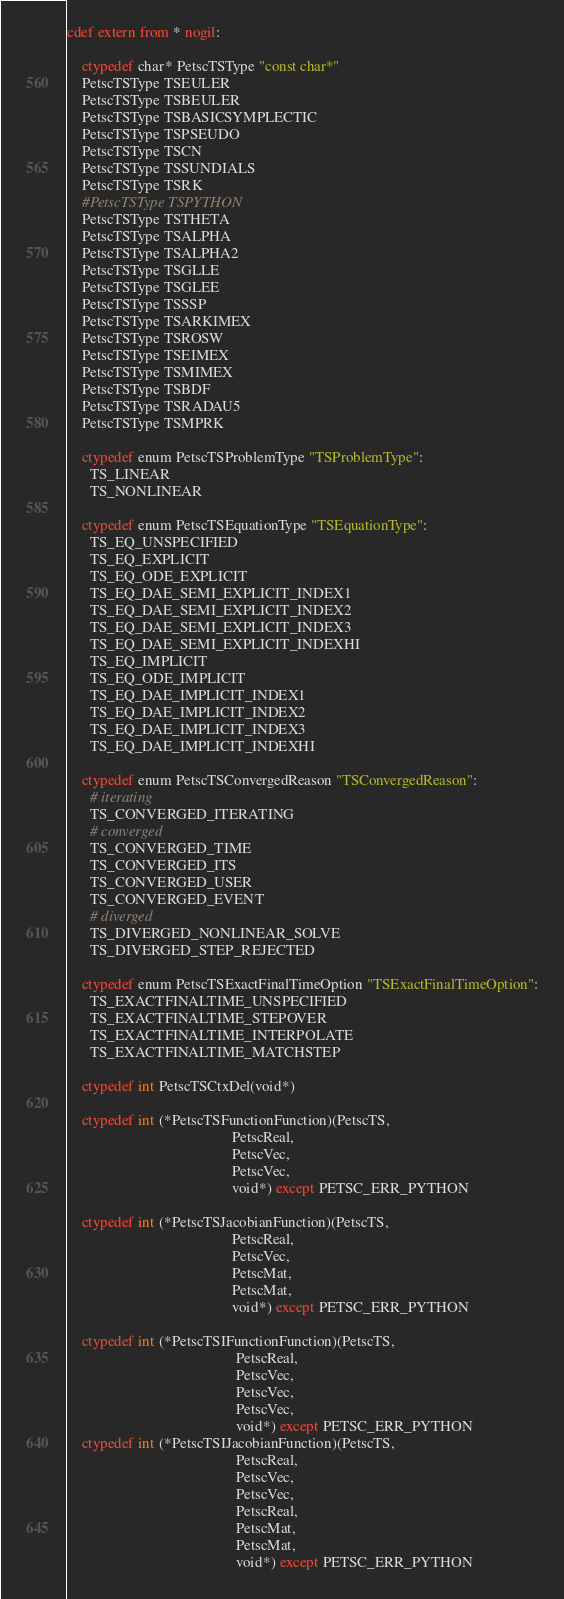Convert code to text. <code><loc_0><loc_0><loc_500><loc_500><_Cython_>cdef extern from * nogil:

    ctypedef char* PetscTSType "const char*"
    PetscTSType TSEULER
    PetscTSType TSBEULER
    PetscTSType TSBASICSYMPLECTIC
    PetscTSType TSPSEUDO
    PetscTSType TSCN
    PetscTSType TSSUNDIALS
    PetscTSType TSRK
    #PetscTSType TSPYTHON
    PetscTSType TSTHETA
    PetscTSType TSALPHA
    PetscTSType TSALPHA2
    PetscTSType TSGLLE
    PetscTSType TSGLEE
    PetscTSType TSSSP
    PetscTSType TSARKIMEX
    PetscTSType TSROSW
    PetscTSType TSEIMEX
    PetscTSType TSMIMEX
    PetscTSType TSBDF
    PetscTSType TSRADAU5
    PetscTSType TSMPRK

    ctypedef enum PetscTSProblemType "TSProblemType":
      TS_LINEAR
      TS_NONLINEAR

    ctypedef enum PetscTSEquationType "TSEquationType":
      TS_EQ_UNSPECIFIED
      TS_EQ_EXPLICIT
      TS_EQ_ODE_EXPLICIT
      TS_EQ_DAE_SEMI_EXPLICIT_INDEX1
      TS_EQ_DAE_SEMI_EXPLICIT_INDEX2
      TS_EQ_DAE_SEMI_EXPLICIT_INDEX3
      TS_EQ_DAE_SEMI_EXPLICIT_INDEXHI
      TS_EQ_IMPLICIT
      TS_EQ_ODE_IMPLICIT
      TS_EQ_DAE_IMPLICIT_INDEX1
      TS_EQ_DAE_IMPLICIT_INDEX2
      TS_EQ_DAE_IMPLICIT_INDEX3
      TS_EQ_DAE_IMPLICIT_INDEXHI

    ctypedef enum PetscTSConvergedReason "TSConvergedReason":
      # iterating
      TS_CONVERGED_ITERATING
      # converged
      TS_CONVERGED_TIME
      TS_CONVERGED_ITS
      TS_CONVERGED_USER
      TS_CONVERGED_EVENT
      # diverged
      TS_DIVERGED_NONLINEAR_SOLVE
      TS_DIVERGED_STEP_REJECTED

    ctypedef enum PetscTSExactFinalTimeOption "TSExactFinalTimeOption":
      TS_EXACTFINALTIME_UNSPECIFIED
      TS_EXACTFINALTIME_STEPOVER
      TS_EXACTFINALTIME_INTERPOLATE
      TS_EXACTFINALTIME_MATCHSTEP

    ctypedef int PetscTSCtxDel(void*)

    ctypedef int (*PetscTSFunctionFunction)(PetscTS,
                                            PetscReal,
                                            PetscVec,
                                            PetscVec,
                                            void*) except PETSC_ERR_PYTHON

    ctypedef int (*PetscTSJacobianFunction)(PetscTS,
                                            PetscReal,
                                            PetscVec,
                                            PetscMat,
                                            PetscMat,
                                            void*) except PETSC_ERR_PYTHON

    ctypedef int (*PetscTSIFunctionFunction)(PetscTS,
                                             PetscReal,
                                             PetscVec,
                                             PetscVec,
                                             PetscVec,
                                             void*) except PETSC_ERR_PYTHON
    ctypedef int (*PetscTSIJacobianFunction)(PetscTS,
                                             PetscReal,
                                             PetscVec,
                                             PetscVec,
                                             PetscReal,
                                             PetscMat,
                                             PetscMat,
                                             void*) except PETSC_ERR_PYTHON
</code> 